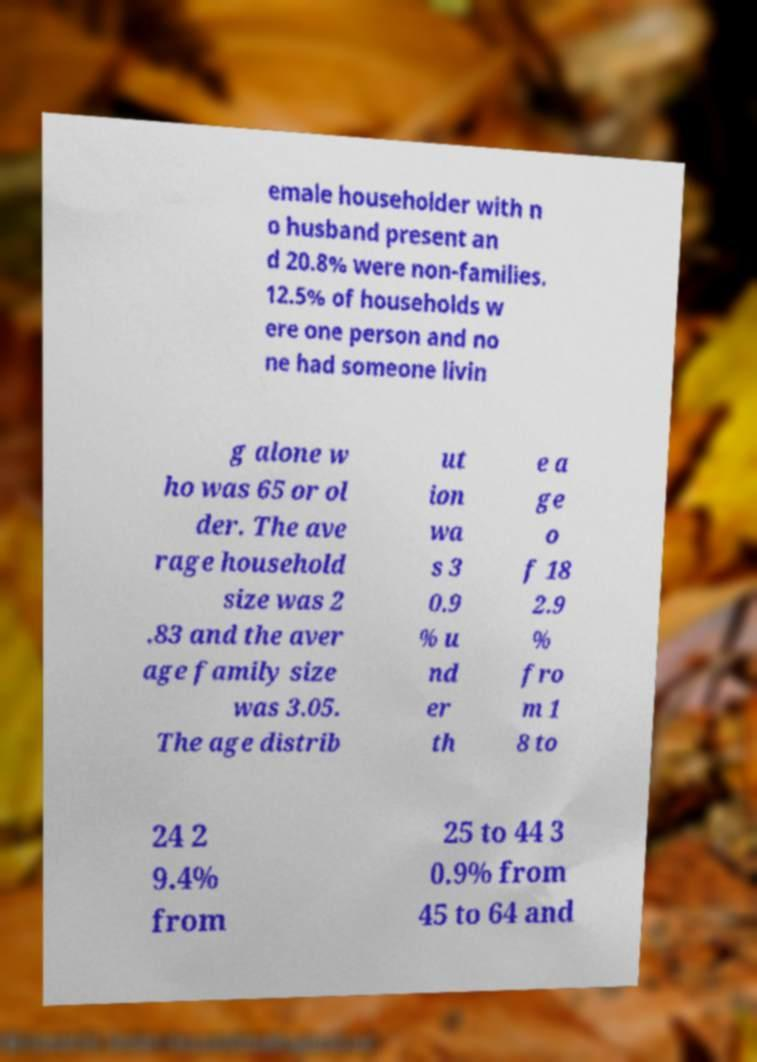Please identify and transcribe the text found in this image. emale householder with n o husband present an d 20.8% were non-families. 12.5% of households w ere one person and no ne had someone livin g alone w ho was 65 or ol der. The ave rage household size was 2 .83 and the aver age family size was 3.05. The age distrib ut ion wa s 3 0.9 % u nd er th e a ge o f 18 2.9 % fro m 1 8 to 24 2 9.4% from 25 to 44 3 0.9% from 45 to 64 and 